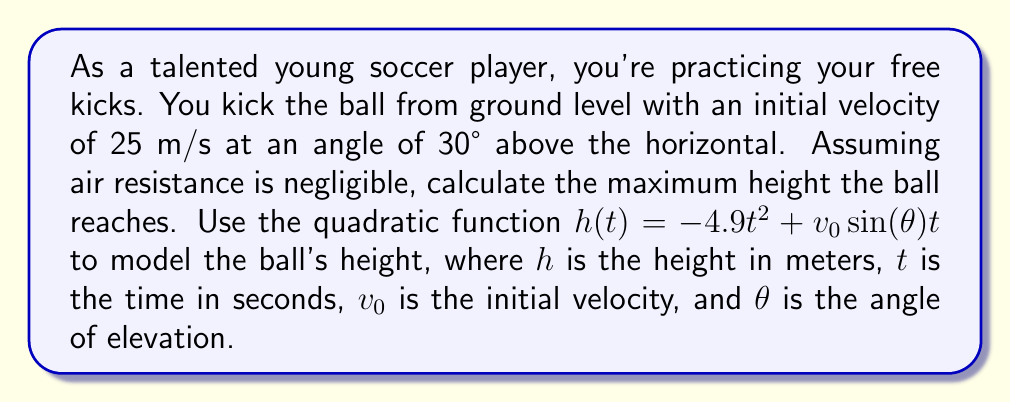Solve this math problem. To solve this problem, we'll follow these steps:

1) First, let's identify the given information:
   $v_0 = 25$ m/s
   $\theta = 30°$

2) We need to use the quadratic function:
   $h(t) = -4.9t^2 + v_0\sin(\theta)t$

3) Substitute the known values:
   $h(t) = -4.9t^2 + 25\sin(30°)t$

4) Calculate $\sin(30°)$:
   $\sin(30°) = 0.5$

5) Our function now becomes:
   $h(t) = -4.9t^2 + 12.5t$

6) To find the maximum height, we need to find the vertex of this parabola. For a quadratic function in the form $f(t) = at^2 + bt + c$, the t-coordinate of the vertex is given by $t = -\frac{b}{2a}$.

7) In our case, $a = -4.9$ and $b = 12.5$. So:
   $t = -\frac{12.5}{2(-4.9)} = \frac{12.5}{9.8} \approx 1.276$ seconds

8) To find the maximum height, we substitute this t-value back into our height function:
   $h(1.276) = -4.9(1.276)^2 + 12.5(1.276)$
              $= -4.9(1.628) + 15.95$
              $= -7.977 + 15.95$
              $= 7.973$ meters

Therefore, the maximum height the ball reaches is approximately 7.973 meters.
Answer: The maximum height the soccer ball reaches is approximately 7.973 meters. 